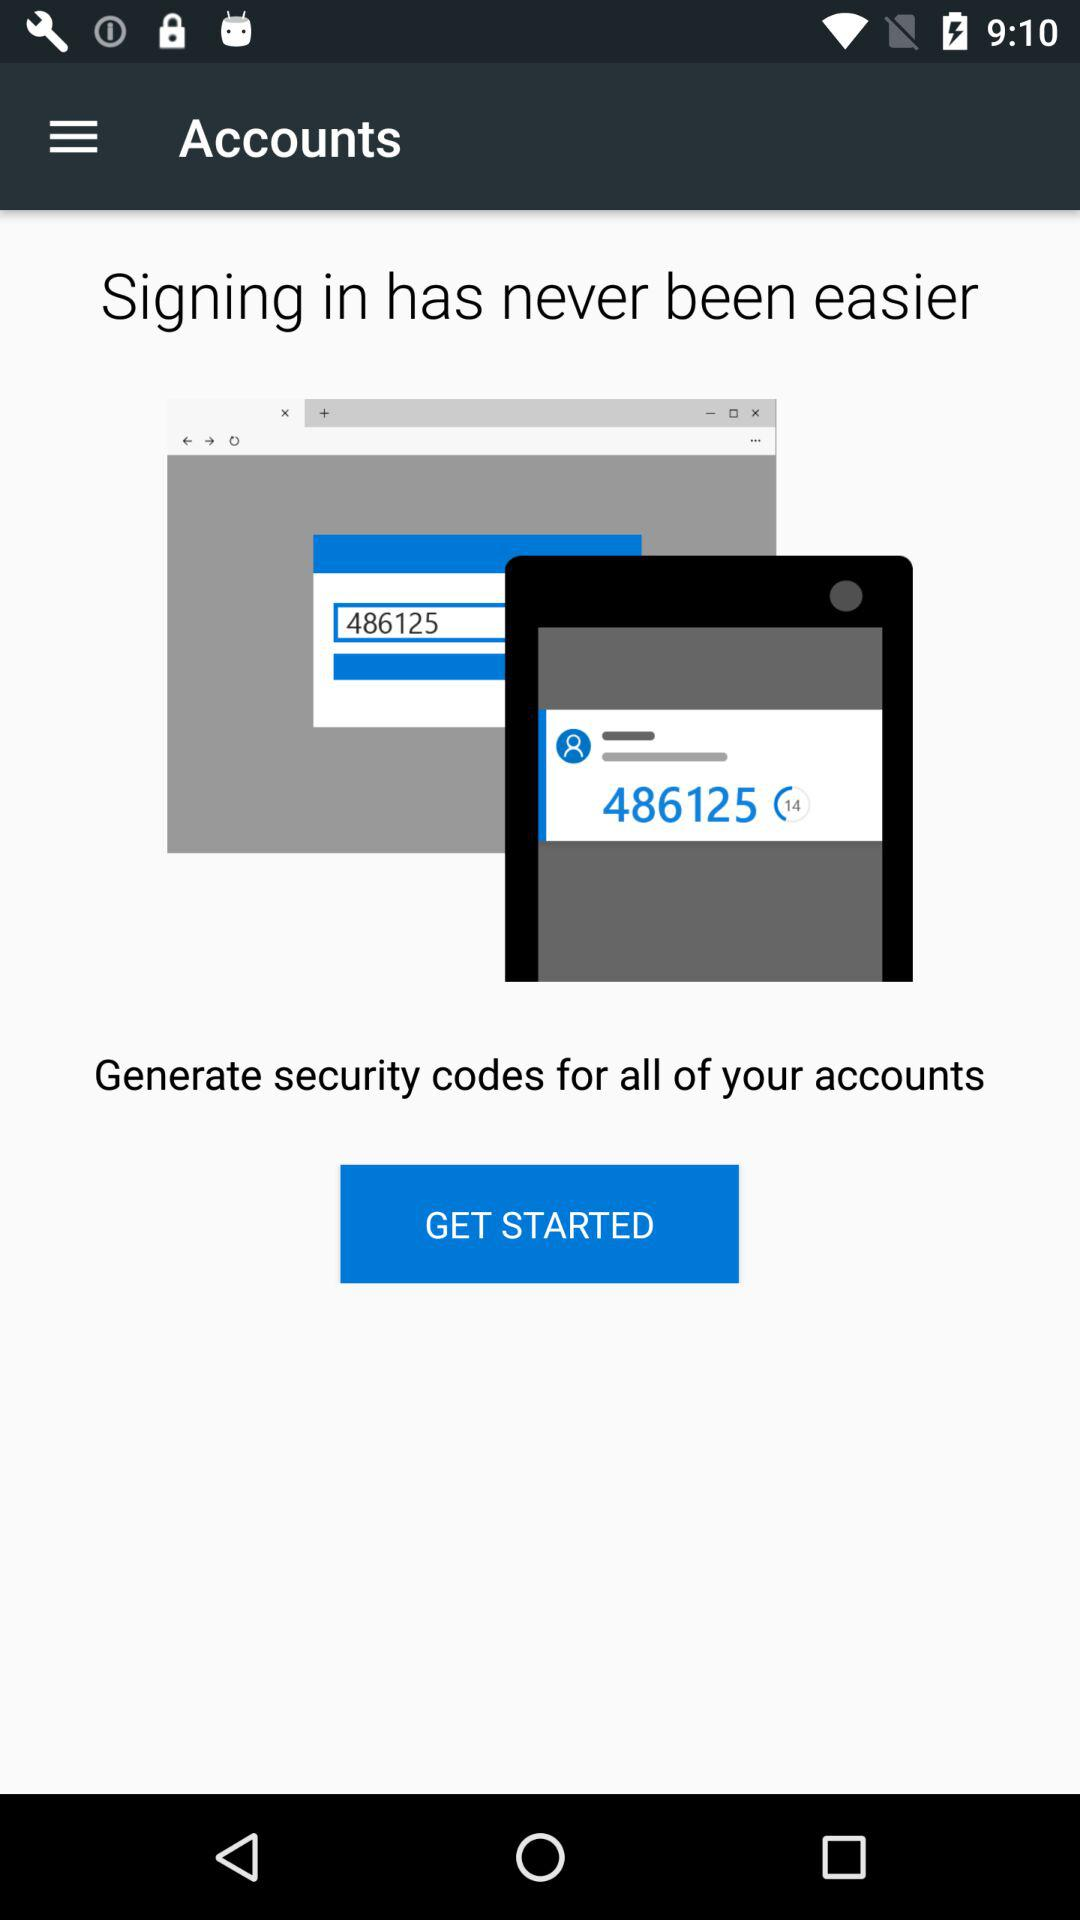What is the name of application?
When the provided information is insufficient, respond with <no answer>. <no answer> 